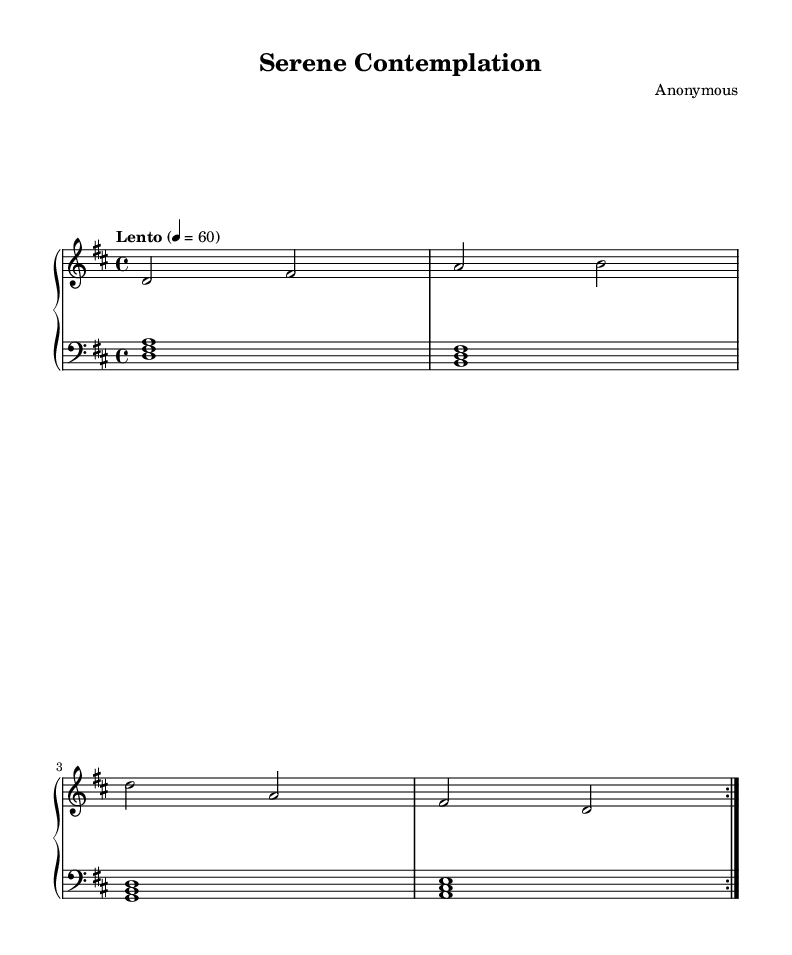What is the key signature of this music? The key signature is determined by the number of sharps or flats at the beginning of the staff. In this case, there are two sharps (F# and C#), indicating it is in D major.
Answer: D major What is the time signature of this music? The time signature is represented by the numbers at the beginning of the staff, indicating how many beats are in a measure and what note value counts as one beat. Here, the time signature is 4/4, meaning there are four beats per measure and a quarter note receives one beat.
Answer: 4/4 What is the tempo marking of this music? The tempo marking is indicated in the score as "Lento" with a metronome marking of 60. This indicates a slow tempo, suggesting a calm and meditative pace.
Answer: Lento How many different melodic sections are in this piece? By examining the repeat markings (volta), we can see the melody is repeated, indicating there are 2 main sections since it repeats twice.
Answer: 2 What is the lowest note played in the left hand? In the left hand, the notes played are written in a bass clef. The lowest note in the provided music is B, as observed in the first measure of the left hand part.
Answer: B What type of music does this piece represent? Given its characteristics, such as the serene tempo, minimalistic harmonies, and ambient instrumentation suitable for meditation, this piece is categorized as religious ambient music.
Answer: Religious ambient music 